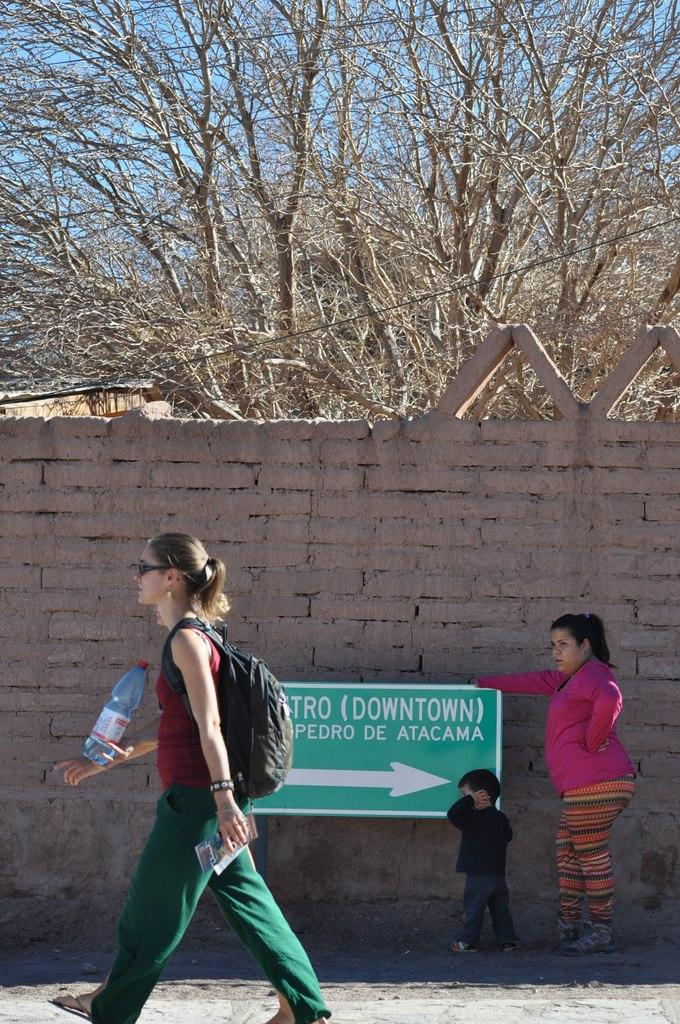How many people are in the image? There are two women and a kid in the image. Where are they located? They are on the road in the image. What is on the wall in the image? There is a board on the wall in the image. What else can be seen in the image? There is a bottle and trees in the background of the image. What is visible in the background of the image? The sky is visible in the background of the image. What type of scent can be detected from the potato in the image? There is no potato present in the image, so it is not possible to detect any scent. 